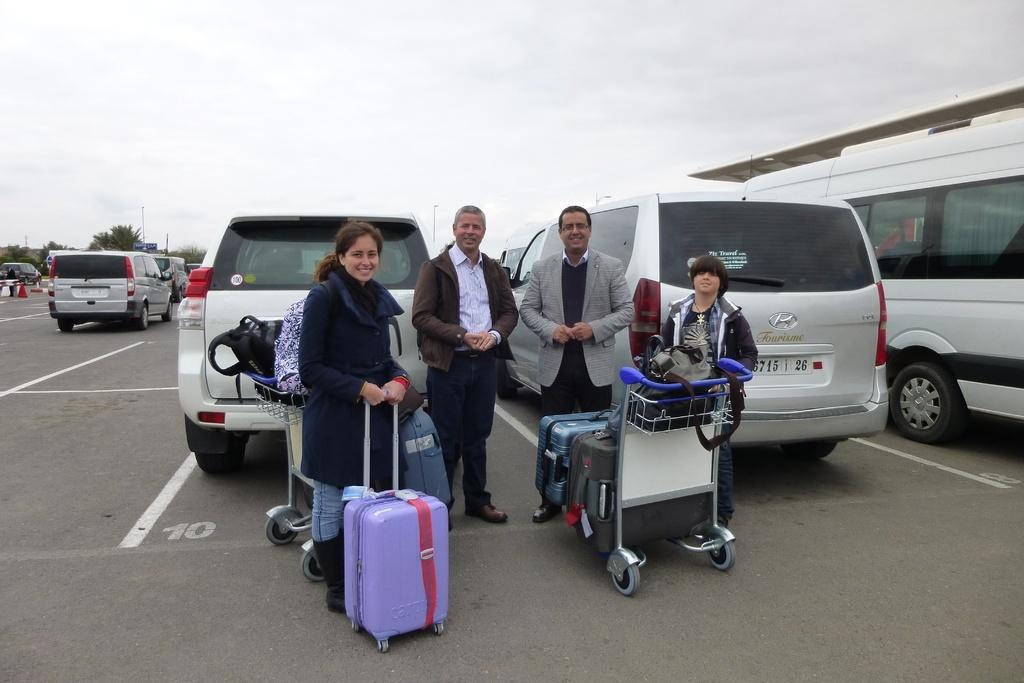What are the people in the image doing? The people in the image are standing on the road. What items are the people likely to be using for their belongings? There are luggage bags in the image, which suggests that the people might be using them for their belongings. What might the people be using to transport their luggage bags? Trolleys are present in the image, which could be used to transport the luggage bags. What else can be seen in the image besides the people and luggage bags? Vehicles, trees, poles, and the sky are visible in the image. What type of air is being respected by the people in the image? There is no mention of air or respect in the image, so it is not possible to answer that question. 